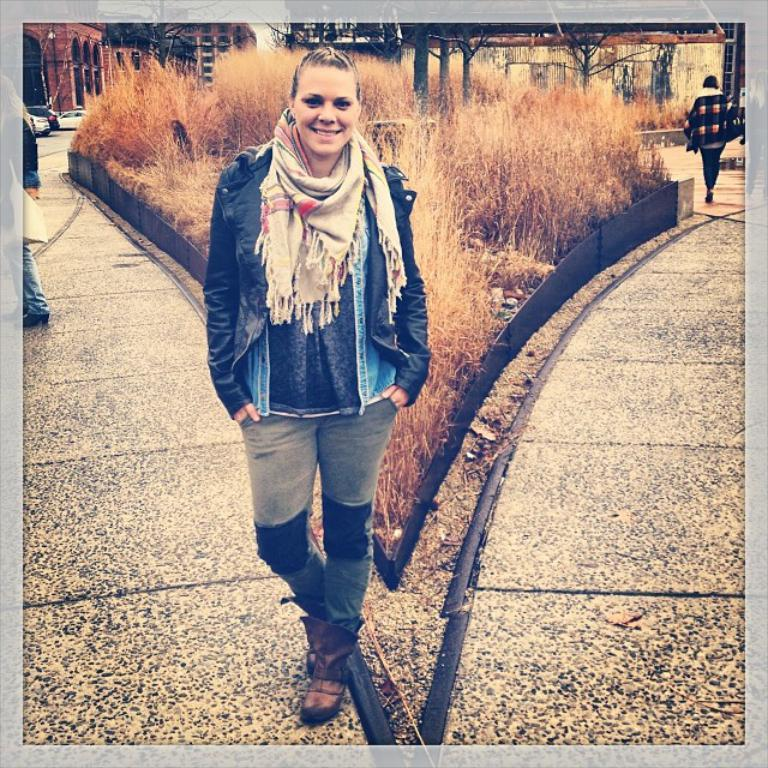Who is the main subject in the image? There is a woman standing in the front of the image. What is the woman doing in the image? The woman is smiling, which suggests a positive or happy emotion. We start by identifying the main subject in the image, which is the woman. Then, we describe her expression and expand the conversation to include other elements in the image, such as the dry grass, buildings, cars, and persons in the background. Each question is designed to elicit a specific detail about the image that is known from the provided facts. Absurd Question/Answer: What is the name of the hand that can be seen holding the plough in the image? There is no hand or plough present in the image. What type of plough is being used by the person in the image? There is no person or plough present in the image. 